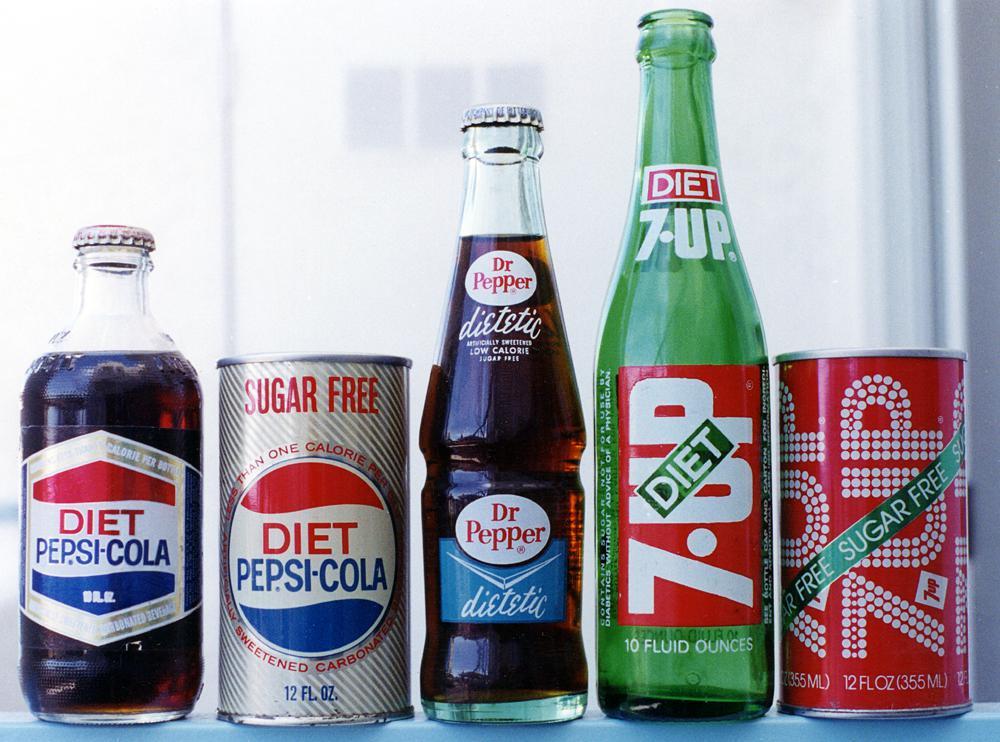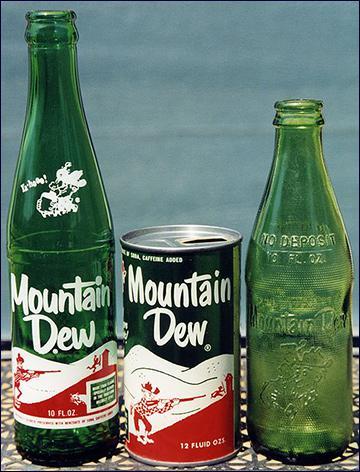The first image is the image on the left, the second image is the image on the right. Given the left and right images, does the statement "There are only 7-up bottles in each image." hold true? Answer yes or no. No. The first image is the image on the left, the second image is the image on the right. Analyze the images presented: Is the assertion "The right image contains two matching green bottles with the same labels, and no image contains cans." valid? Answer yes or no. No. 